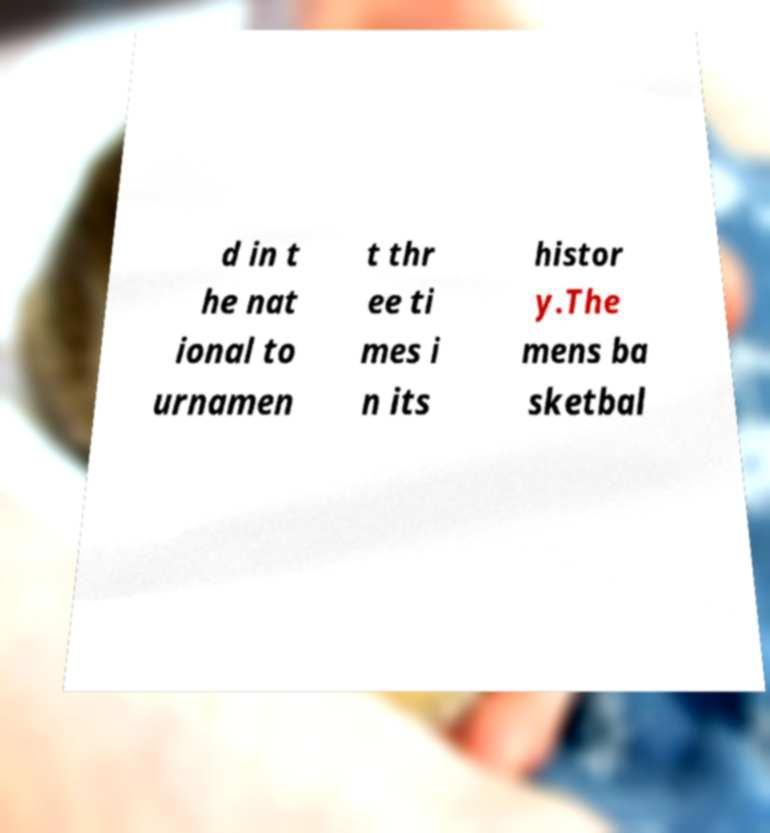Could you extract and type out the text from this image? d in t he nat ional to urnamen t thr ee ti mes i n its histor y.The mens ba sketbal 